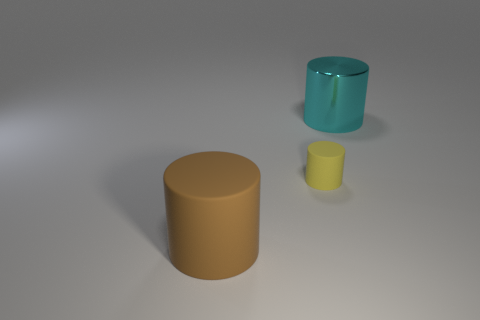What is the shape of the cyan shiny object that is the same size as the brown thing?
Offer a terse response. Cylinder. Is the shiny object the same shape as the small yellow object?
Give a very brief answer. Yes. How many other rubber things have the same shape as the brown thing?
Ensure brevity in your answer.  1. There is a small yellow rubber cylinder; what number of large cylinders are in front of it?
Make the answer very short. 1. How many blocks have the same size as the brown cylinder?
Offer a terse response. 0. What is the shape of the large brown thing that is made of the same material as the small thing?
Make the answer very short. Cylinder. What is the large brown cylinder made of?
Keep it short and to the point. Rubber. What number of objects are tiny rubber objects or big cyan cylinders?
Make the answer very short. 2. There is a matte thing to the right of the large brown cylinder; how big is it?
Ensure brevity in your answer.  Small. How many other things are the same material as the big cyan cylinder?
Offer a terse response. 0. 